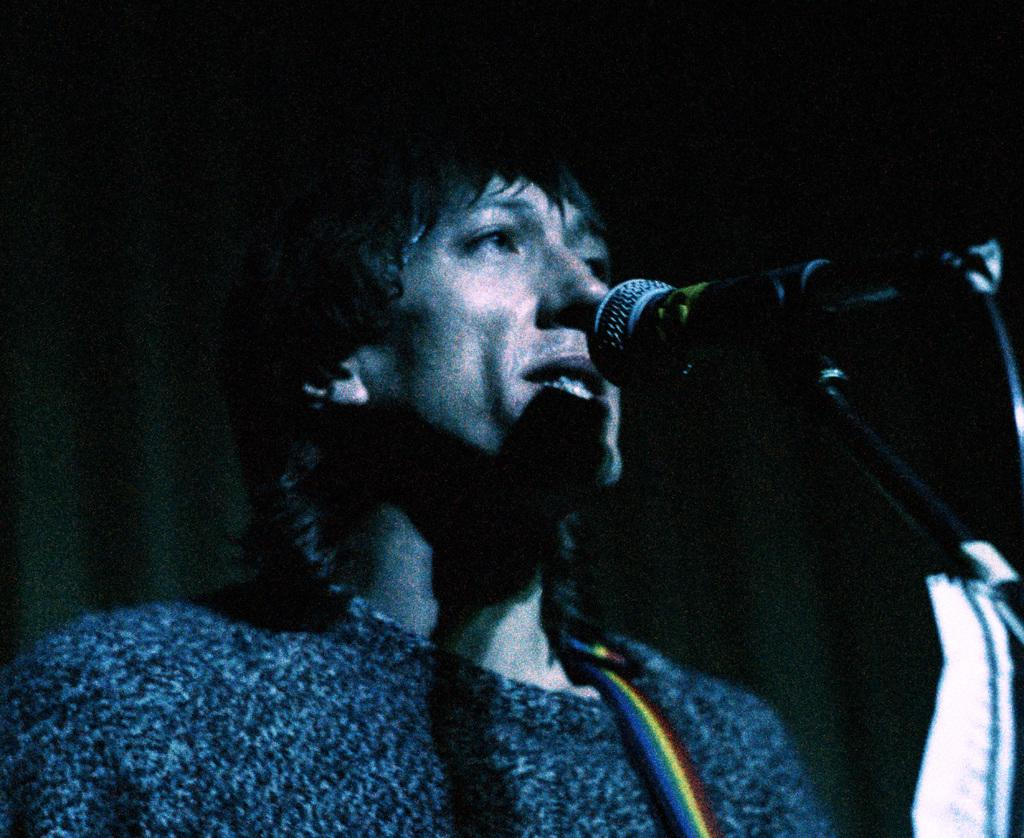What is the person in the image doing? The person is singing in the image. What object is present on the right side of the image? There is a microphone with a stand on the right side of the image. What can be observed about the background of the image? The background of the image is dark. Can you see any nuts or soda in the image? No, there are no nuts or soda present in the image. Does the person in the image have a tail? No, the person in the image does not have a tail. 